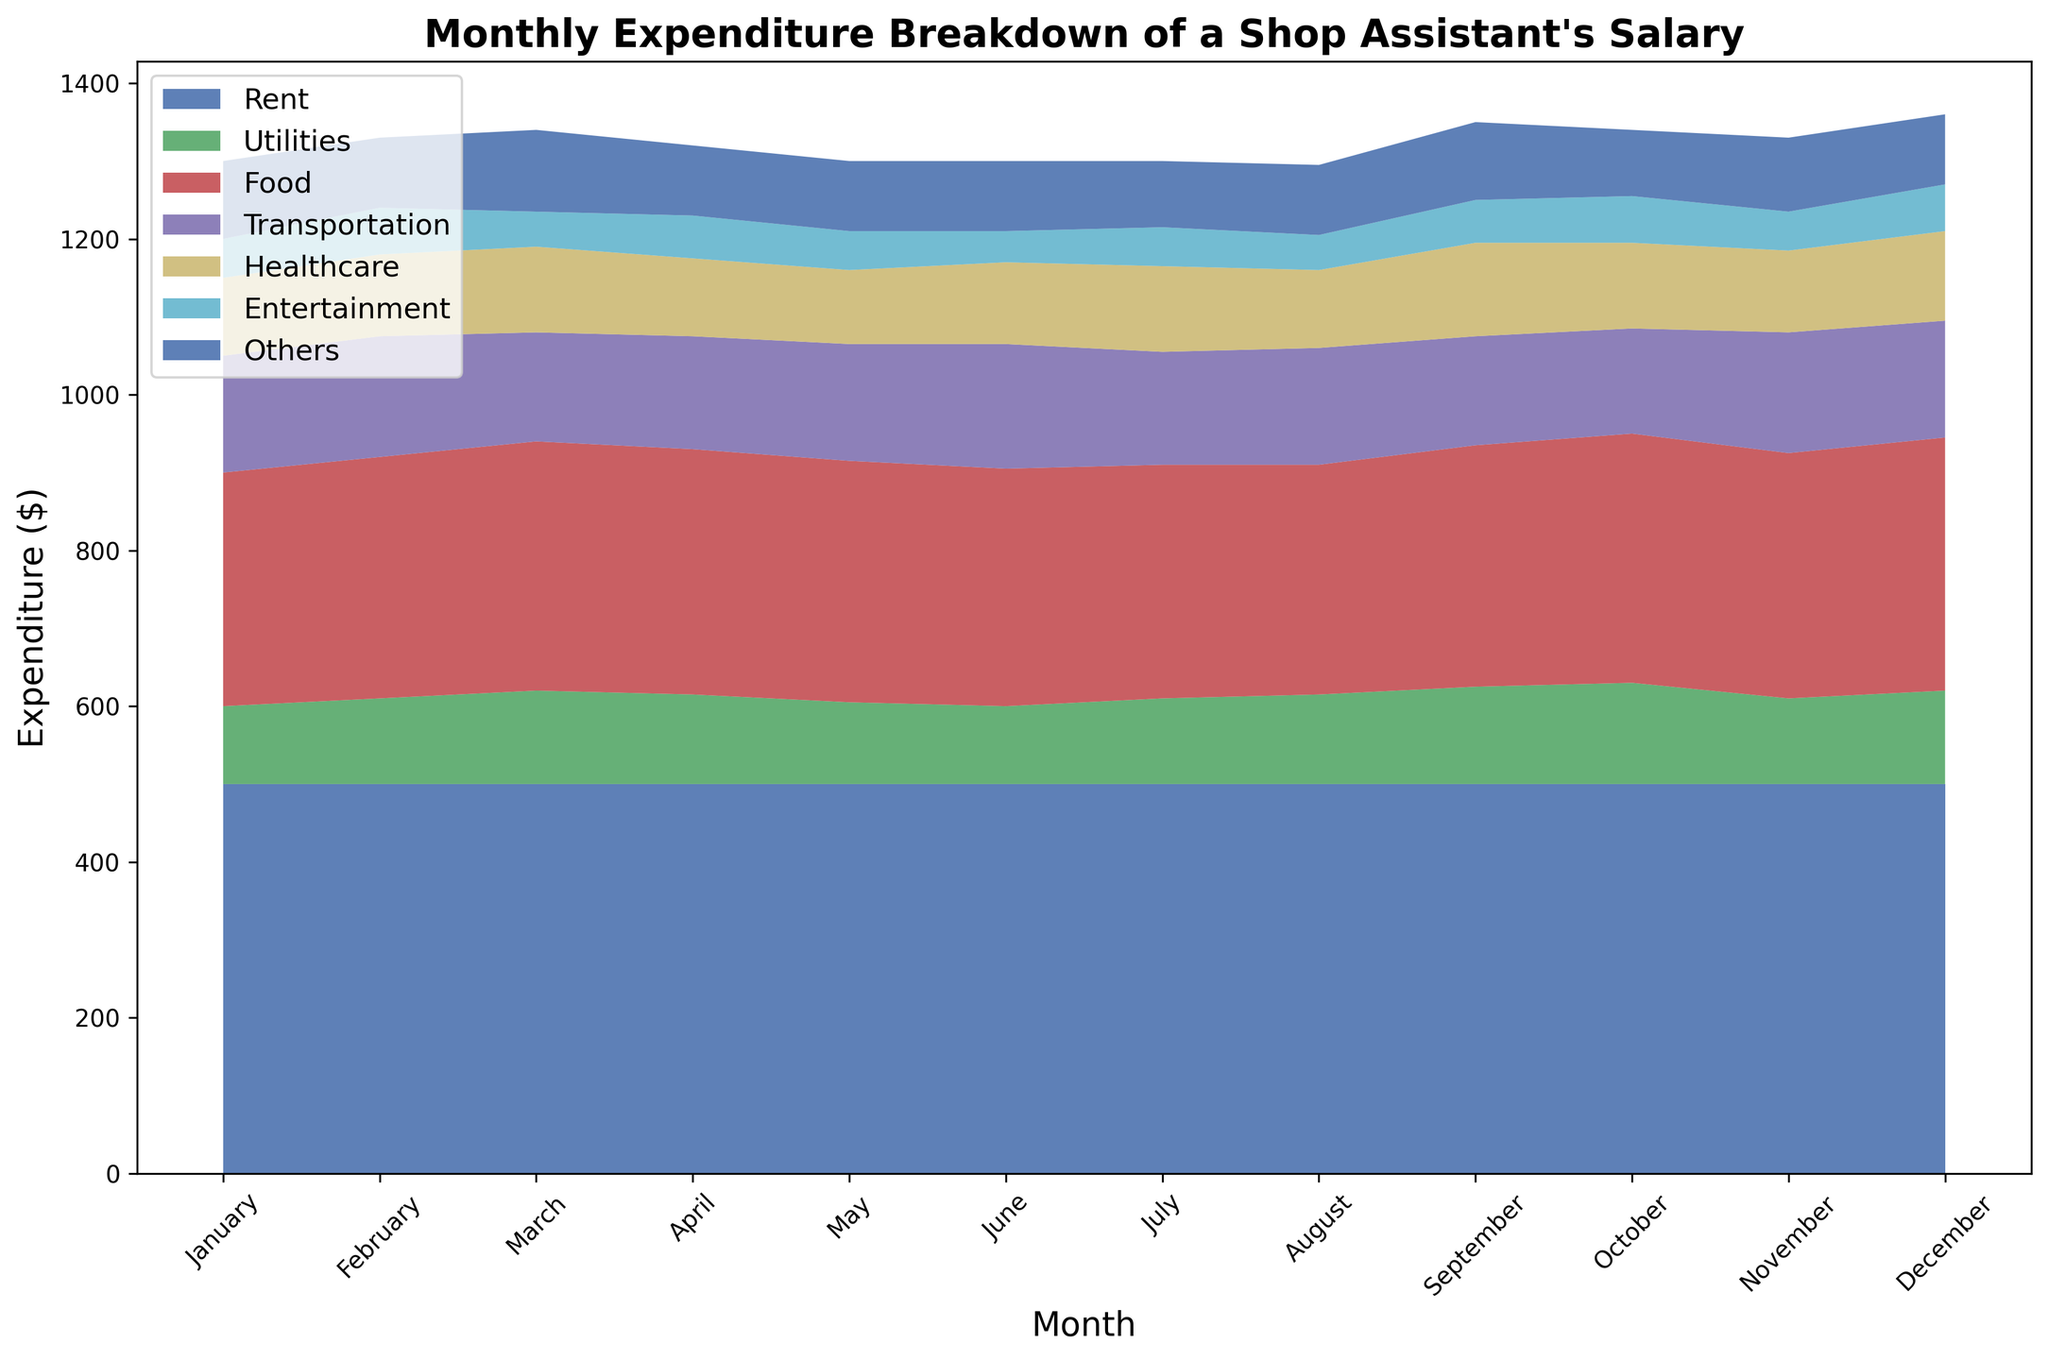What is the total expenditure for February? Look at February's data on the chart. Add up all the individual expenditures for that month: Rent (500) + Utilities (110) + Food (310) + Transportation (155) + Healthcare (105) + Entertainment (60) + Others (90).
Answer: 1330 Which month had the highest expenditure on Food? Observe the Food expenditure line (likely colored differently for distinction) across all months. Identify the peak point visually. You see that December has the highest point for Food at 325.
Answer: December What is the average monthly expenditure on Healthcare? Add up the Healthcare expenditures for all the months (100 + 105 + 110 + 100 + 95 + 105 + 110 + 100 + 120 + 110 + 105 + 115) = 1275. Then, divide by 12 (months): 1275 / 12.
Answer: 106.25 How does the entertainment expenditure in April compare to that in October? Find the details for Entertainment in both months from the chart: April (55) and October (60). Compare numerically: 55 in April is less than 60 in October.
Answer: Less in April What is the difference in total expenditure between June and August? Calculate the total expenditure for June (500 + 100 + 305 + 160 + 105 + 40 + 90 = 1300) and for August (500 + 115 + 295 + 150 + 100 + 45 + 90 = 1295). The difference is 1300 - 1295.
Answer: 5 Which category shows the most fluctuation throughout the year? Visually compare the variation (amplitude changes) of the different categories in the chart. Identify that Utilities and Transportation show significant changes, but Utilities fluctuates more visibly between 100 and 130.
Answer: Utilities How does the total expenditure in July compare to that in March? Calculate total expenditure for March (500 + 120 + 320 + 140 + 110 + 45 + 105 = 1340) and for July (500 + 110 + 300 + 145 + 110 + 50 + 85 = 1300). July is lesser than March.
Answer: July is less What is the average monthly expenditure on Rent? Given that Rent is consistently 500 every month, the average monthly expenditure on Rent is simply 500, as it does not vary.
Answer: 500 How did Transportation expenses vary from January to June? Note the changes in Transportation from January to June (150, 155, 140, 145, 150, 160). Track the values and observe the upward and downward variations. In general, there is a slight increase from 150 to 160 with small fluctuations.
Answer: Increased slightly What is the combined expenditure for Entertainment and Others in March? Identify the expenditure for Entertainment (45) and Others (105) in March. Add these two values together: 45 + 105.
Answer: 150 